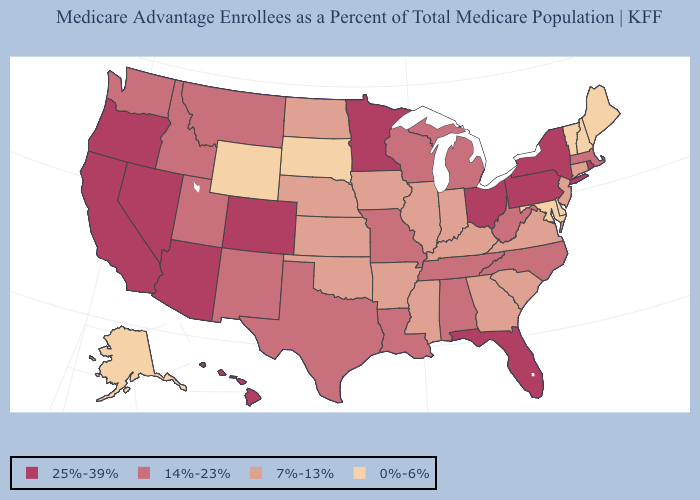How many symbols are there in the legend?
Quick response, please. 4. Does the first symbol in the legend represent the smallest category?
Write a very short answer. No. Among the states that border Montana , does Idaho have the highest value?
Be succinct. Yes. Does the first symbol in the legend represent the smallest category?
Concise answer only. No. Among the states that border Georgia , does South Carolina have the lowest value?
Keep it brief. Yes. What is the lowest value in the USA?
Quick response, please. 0%-6%. What is the lowest value in the USA?
Give a very brief answer. 0%-6%. What is the value of Texas?
Quick response, please. 14%-23%. What is the highest value in the West ?
Quick response, please. 25%-39%. Name the states that have a value in the range 14%-23%?
Quick response, please. Alabama, Idaho, Louisiana, Massachusetts, Michigan, Missouri, Montana, North Carolina, New Mexico, Tennessee, Texas, Utah, Washington, Wisconsin, West Virginia. What is the value of Iowa?
Short answer required. 7%-13%. Name the states that have a value in the range 25%-39%?
Concise answer only. Arizona, California, Colorado, Florida, Hawaii, Minnesota, Nevada, New York, Ohio, Oregon, Pennsylvania, Rhode Island. Name the states that have a value in the range 7%-13%?
Concise answer only. Arkansas, Connecticut, Georgia, Iowa, Illinois, Indiana, Kansas, Kentucky, Mississippi, North Dakota, Nebraska, New Jersey, Oklahoma, South Carolina, Virginia. Which states have the lowest value in the MidWest?
Keep it brief. South Dakota. Which states have the lowest value in the MidWest?
Answer briefly. South Dakota. 